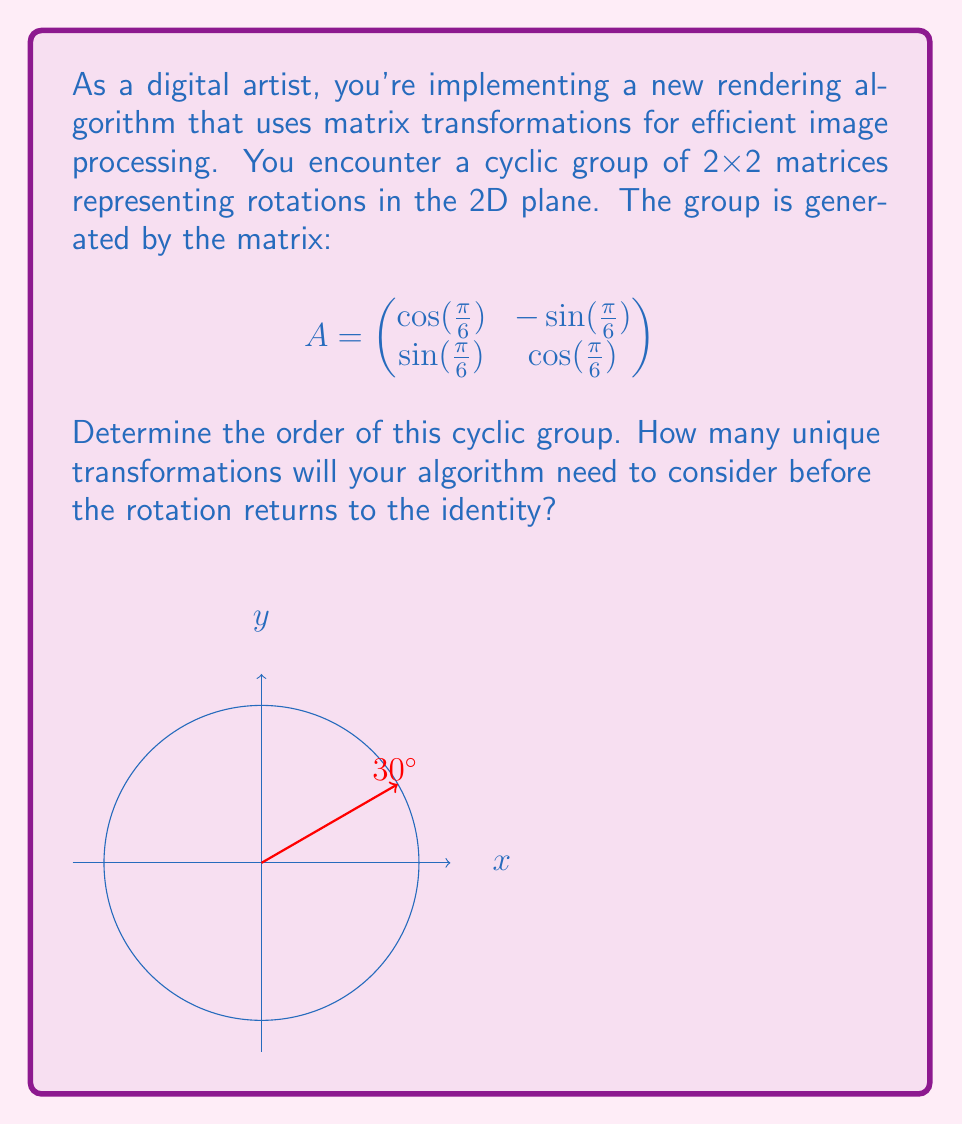Show me your answer to this math problem. Let's approach this step-by-step:

1) The matrix $A$ represents a rotation by $\frac{\pi}{6}$ radians or 30°.

2) To find the order of the cyclic group, we need to determine how many times we must apply this rotation to return to the identity (a full 360° rotation).

3) Mathematically, we're looking for the smallest positive integer $n$ such that $A^n = I$, where $I$ is the identity matrix.

4) We can calculate this by dividing a full rotation by the angle of rotation:

   $$n = \frac{2\pi}{\frac{\pi}{6}} = \frac{2\pi}{\pi} \cdot 6 = 12$$

5) This means that after 12 applications of the rotation, we'll complete a full 360° and return to the starting position.

6) We can verify this:
   $12 \cdot 30° = 360°$

7) Therefore, the cyclic group generated by $A$ has 12 unique elements, corresponding to rotations of 0°, 30°, 60°, ..., 330°.
Answer: 12 